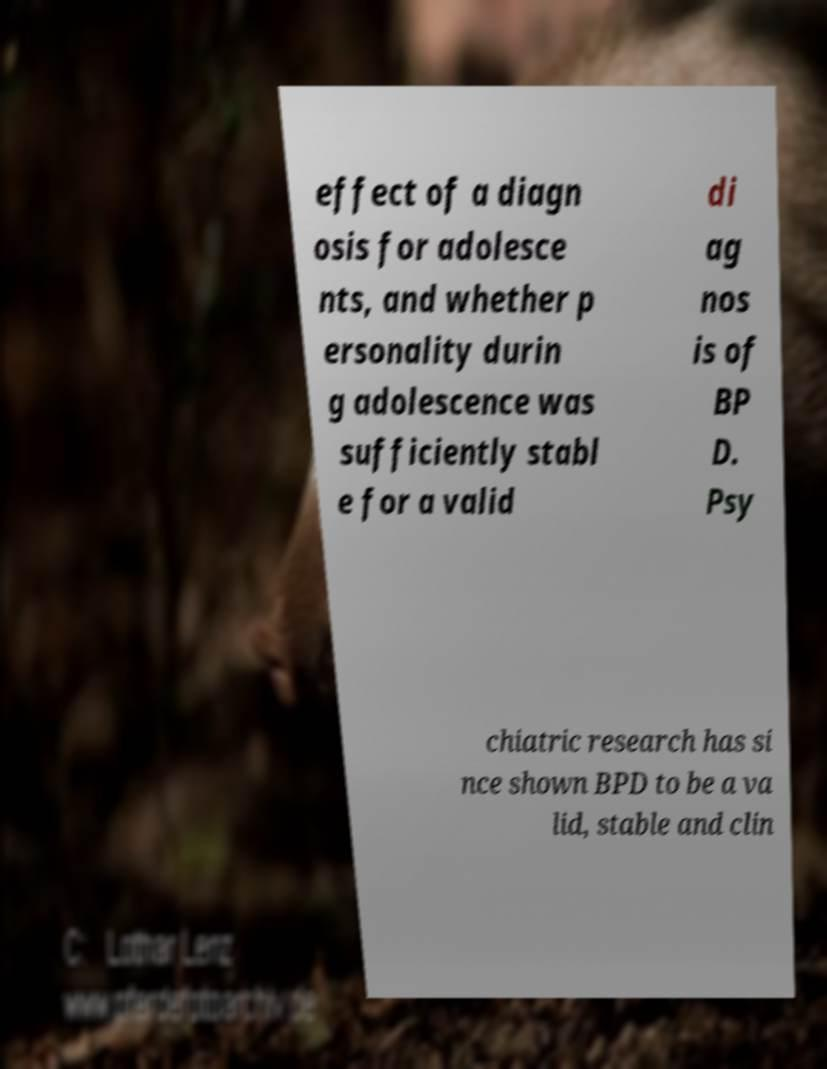Please read and relay the text visible in this image. What does it say? effect of a diagn osis for adolesce nts, and whether p ersonality durin g adolescence was sufficiently stabl e for a valid di ag nos is of BP D. Psy chiatric research has si nce shown BPD to be a va lid, stable and clin 